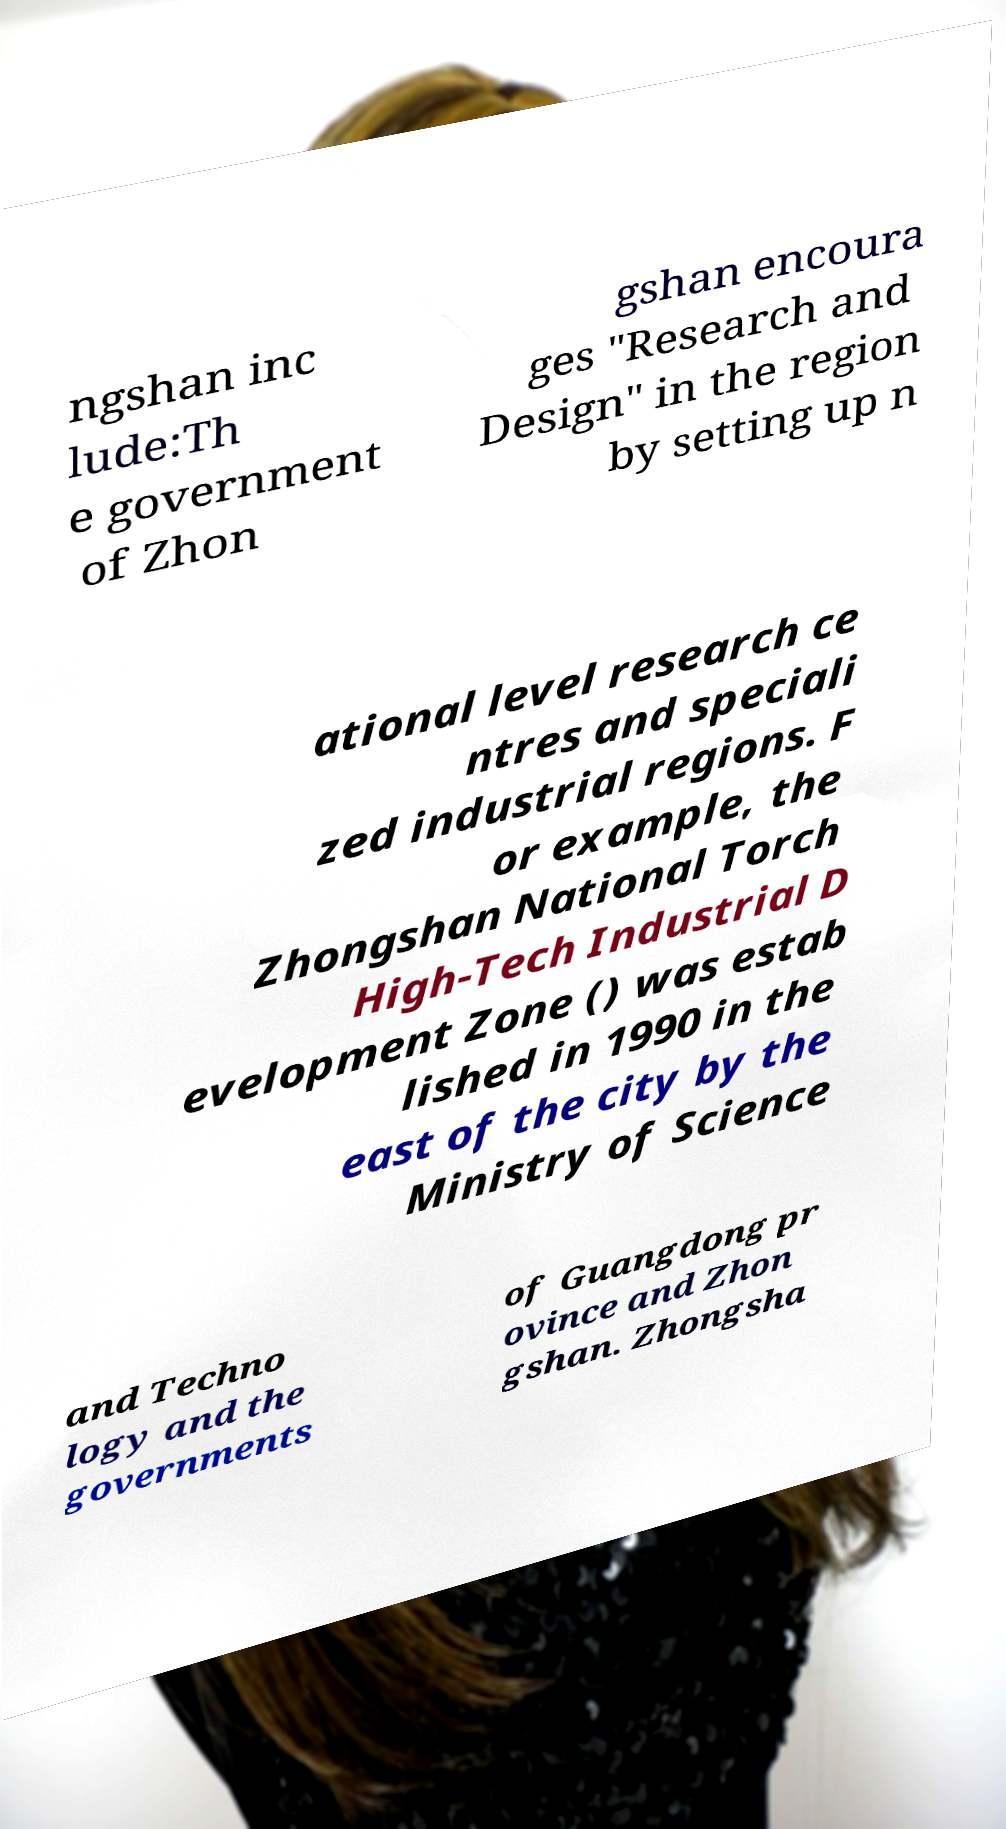I need the written content from this picture converted into text. Can you do that? ngshan inc lude:Th e government of Zhon gshan encoura ges "Research and Design" in the region by setting up n ational level research ce ntres and speciali zed industrial regions. F or example, the Zhongshan National Torch High-Tech Industrial D evelopment Zone () was estab lished in 1990 in the east of the city by the Ministry of Science and Techno logy and the governments of Guangdong pr ovince and Zhon gshan. Zhongsha 